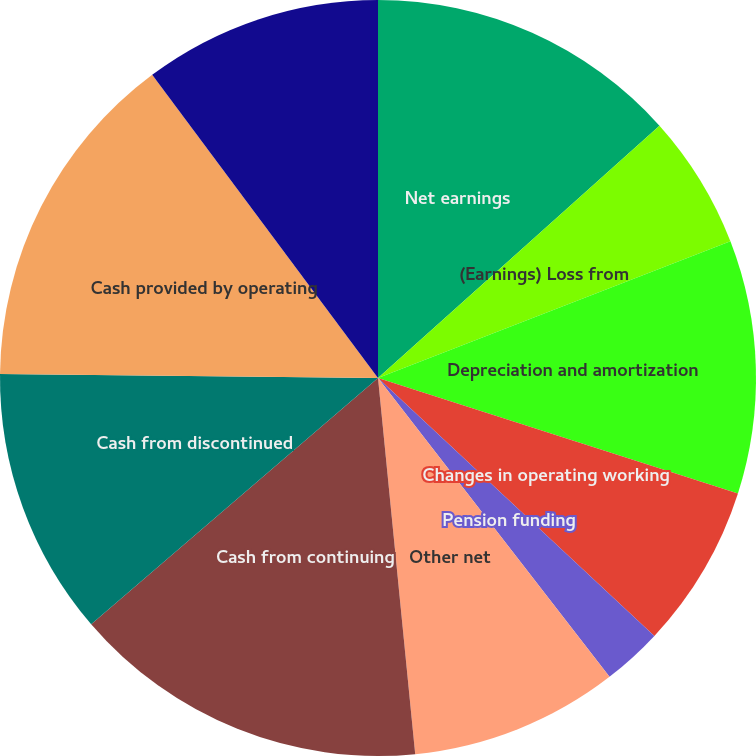<chart> <loc_0><loc_0><loc_500><loc_500><pie_chart><fcel>Net earnings<fcel>(Earnings) Loss from<fcel>Depreciation and amortization<fcel>Changes in operating working<fcel>Pension funding<fcel>Other net<fcel>Cash from continuing<fcel>Cash from discontinued<fcel>Cash provided by operating<fcel>Capital expenditures<nl><fcel>13.37%<fcel>5.74%<fcel>10.83%<fcel>7.01%<fcel>2.56%<fcel>8.92%<fcel>15.28%<fcel>11.46%<fcel>14.64%<fcel>10.19%<nl></chart> 